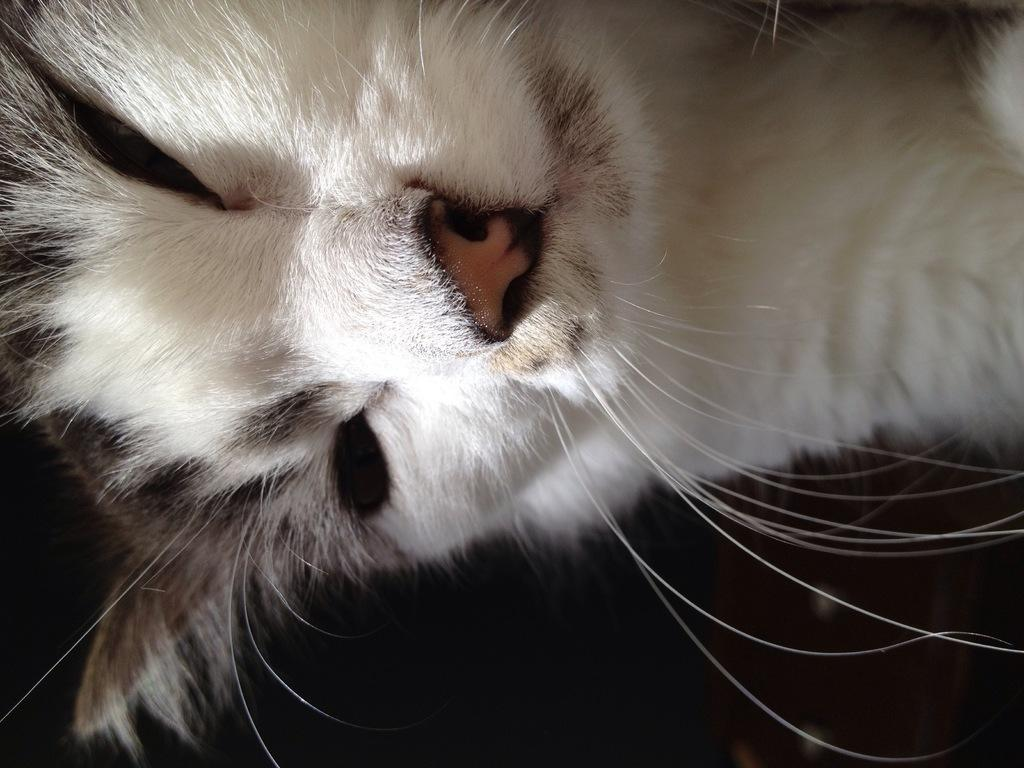What is the main subject in the foreground of the image? There is a cat in the foreground of the image. What can be observed about the background of the image? The background of the image is dark. What type of desk can be seen in the hospital in the image? There is no desk or hospital present in the image; it features a cat in the foreground and a dark background. 